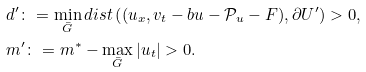<formula> <loc_0><loc_0><loc_500><loc_500>& d ^ { \prime } \colon = \min _ { \bar { G } } d i s t \left ( ( u _ { x } , v _ { t } - b u - \mathcal { P } _ { u } - F ) , \partial U ^ { \prime } \right ) > 0 , \\ & m ^ { \prime } \colon = m ^ { * } - \max _ { \bar { G } } | u _ { t } | > 0 .</formula> 